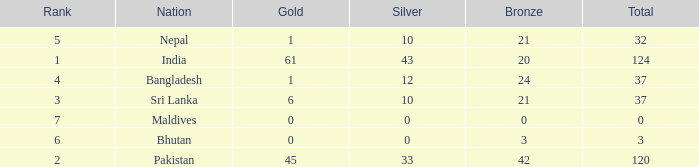How much Silver has a Rank of 7? 1.0. 